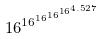Convert formula to latex. <formula><loc_0><loc_0><loc_500><loc_500>1 6 ^ { 1 6 ^ { 1 6 ^ { 1 6 ^ { 1 6 ^ { 4 . 5 2 7 } } } } }</formula> 